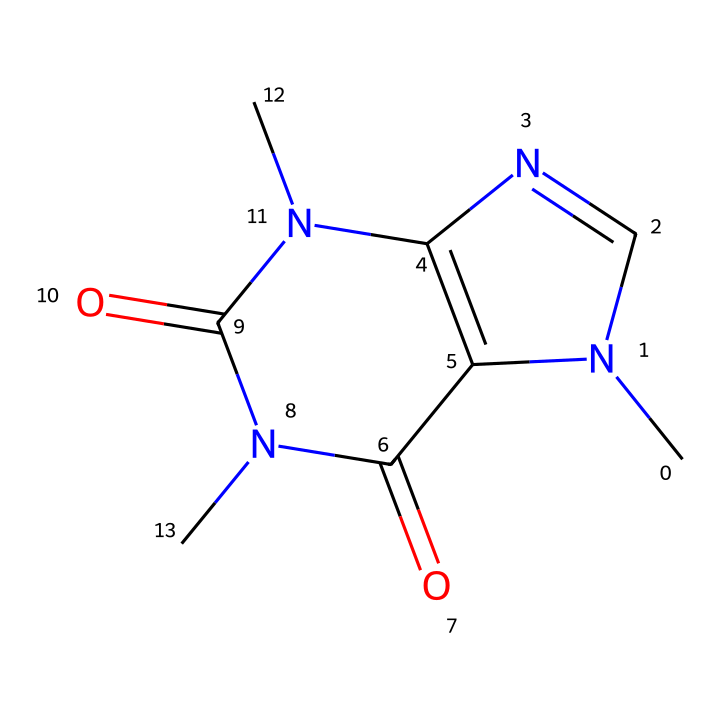What is the molecular formula of caffeine? To find the molecular formula, count the number of each type of atom in the SMILES representation. The structure indicates that caffeine has 8 carbon (C) atoms, 10 hydrogen (H) atoms, 4 nitrogen (N) atoms, and 2 oxygen (O) atoms. Therefore, the molecular formula is C8H10N4O2.
Answer: C8H10N4O2 How many nitrogen atoms are present in caffeine? In the provided SMILES representation, there are 4 nitrogen (N) atoms indicated. You can count the instances where 'N' appears in the structure to arrive at this total.
Answer: 4 What type of compound is caffeine classified as? Caffeine is classified as an alkaloid due to its nitrogen-containing structure and its physiological effects. Alkaloids are typically characterized by their basic nature and pharmacological properties.
Answer: alkaloid What is the number of rings present in the caffeine structure? The caffeine structure includes two interconnected rings in its chemical structure, which can be visualized through the SMILES representation indicating the cyclic nature of the compound.
Answer: 2 How does caffeine primarily affect the human brain? Caffeine primarily acts as a central nervous system stimulant by blocking adenosine receptors. This interaction increases alertness and reduces the perception of fatigue, leading to heightened alertness.
Answer: stimulant 